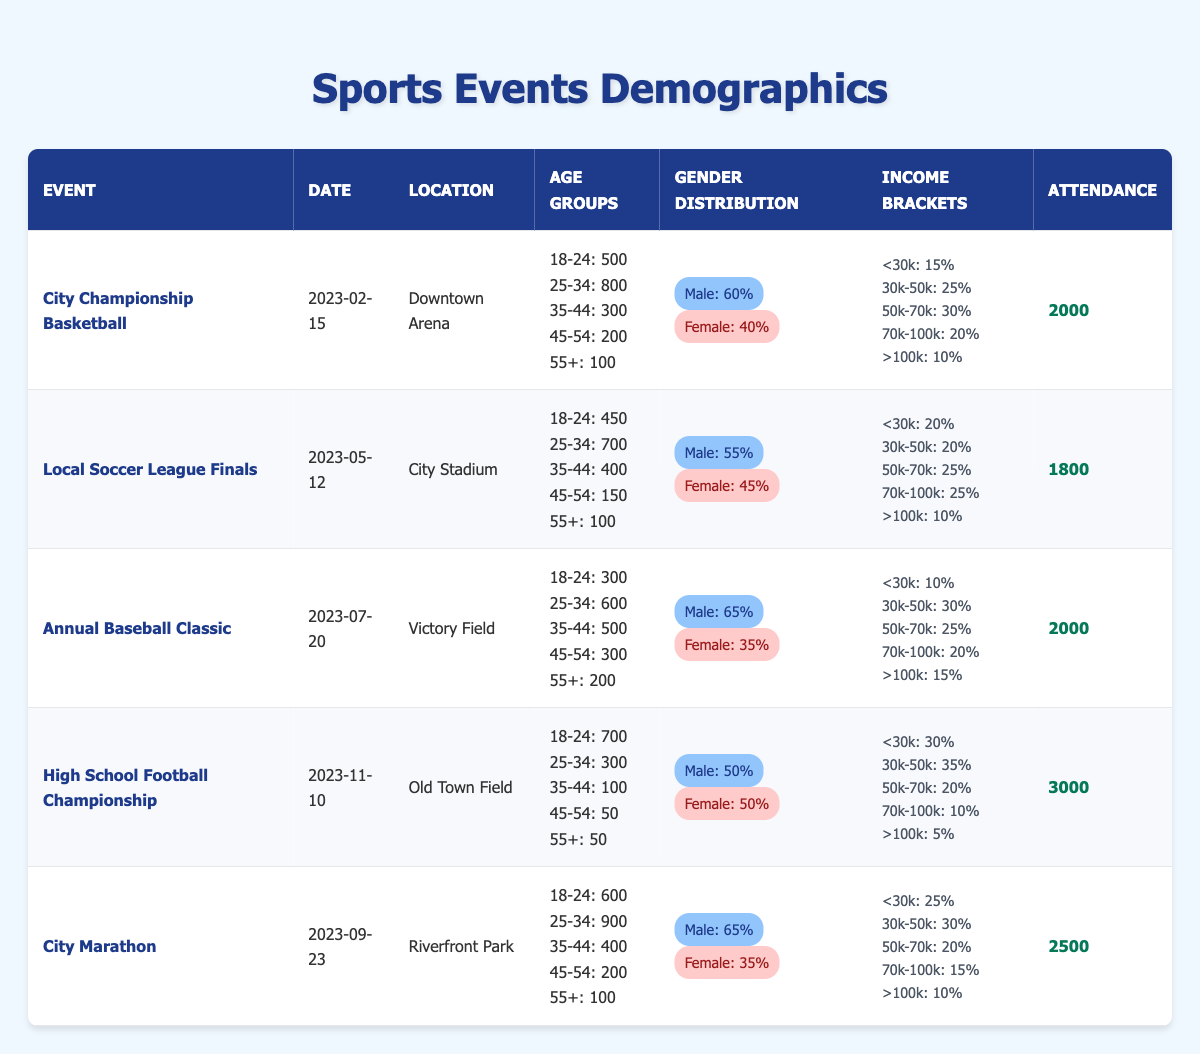What is the total attendance for the City Championship Basketball event? The table shows that the attendance for the City Championship Basketball event is 2000.
Answer: 2000 What percentage of attendees were female at the Annual Baseball Classic? The table indicates that 35% of attendees at the Annual Baseball Classic were female.
Answer: 35% Which event had the highest number of attendees? By inspecting the attendance figures, the High School Football Championship had the highest attendance at 3000.
Answer: 3000 How many attendees were in the age group 25-34 for the Local Soccer League Finals? The age group 25-34 for the Local Soccer League Finals shows an attendance of 700.
Answer: 700 What is the average attendance across all events listed? The total attendance figures add up to 12,800 (2000 + 1800 + 2000 + 3000 + 2500), and there are 5 events. Thus, the average attendance is 12,800 / 5 = 2560.
Answer: 2560 Did any event have more attendees in the 18-24 age group than the 25-34 age group? By comparing the numbers, the High School Football Championship had 700 attendees aged 18-24 while only having 300 attendees aged 25-34, confirming it did.
Answer: Yes Which gender had a larger representation at the City Marathon? The City Marathon demographics show that 65% of attendees were male, which is greater than the 35% who were female.
Answer: Male In the income bracket of "<30k", which event had the highest percentage? Looking at the percentages, the High School Football Championship had the highest percentage of attendees (30%) earning less than 30k.
Answer: 30% How many attendees aged 55 and over were recorded for the Annual Baseball Classic? The Annual Baseball Classic shows that there were 200 attendees aged 55 and over.
Answer: 200 What is the difference in attendance between the City Championship Basketball and the Annual Baseball Classic? The City Championship Basketball had an attendance of 2000, while the Annual Baseball Classic also had 2000. Therefore, the difference is 2000 - 2000 = 0.
Answer: 0 Is there a higher percentage of attendees with an income of ">100k" at the High School Football Championship compared to the Local Soccer League Finals? The High School Football Championship shows 5% of attendees earn over 100k, while the Local Soccer League Finals shows 10%, so this is false.
Answer: No 